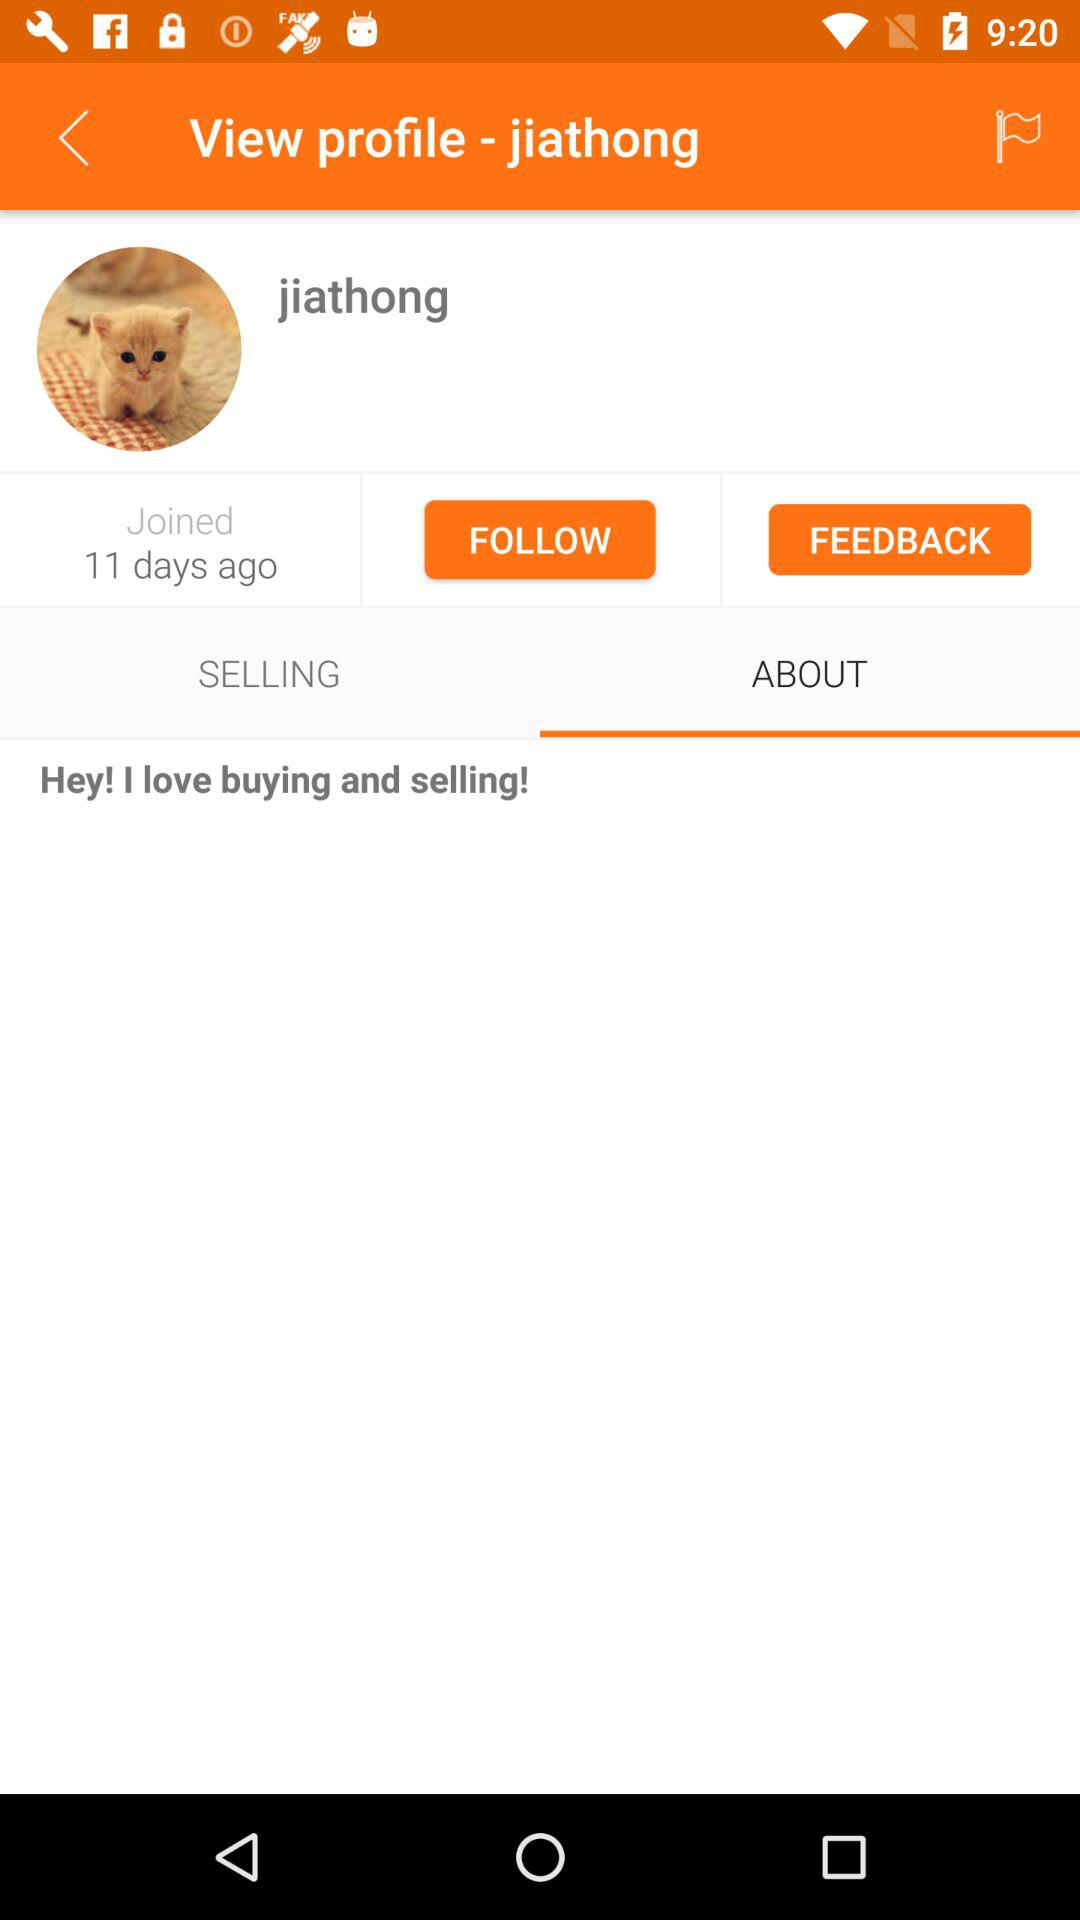What is written in "ABOUT"? In "ABOUT", "Hey! I love buying and selling!" is written. 